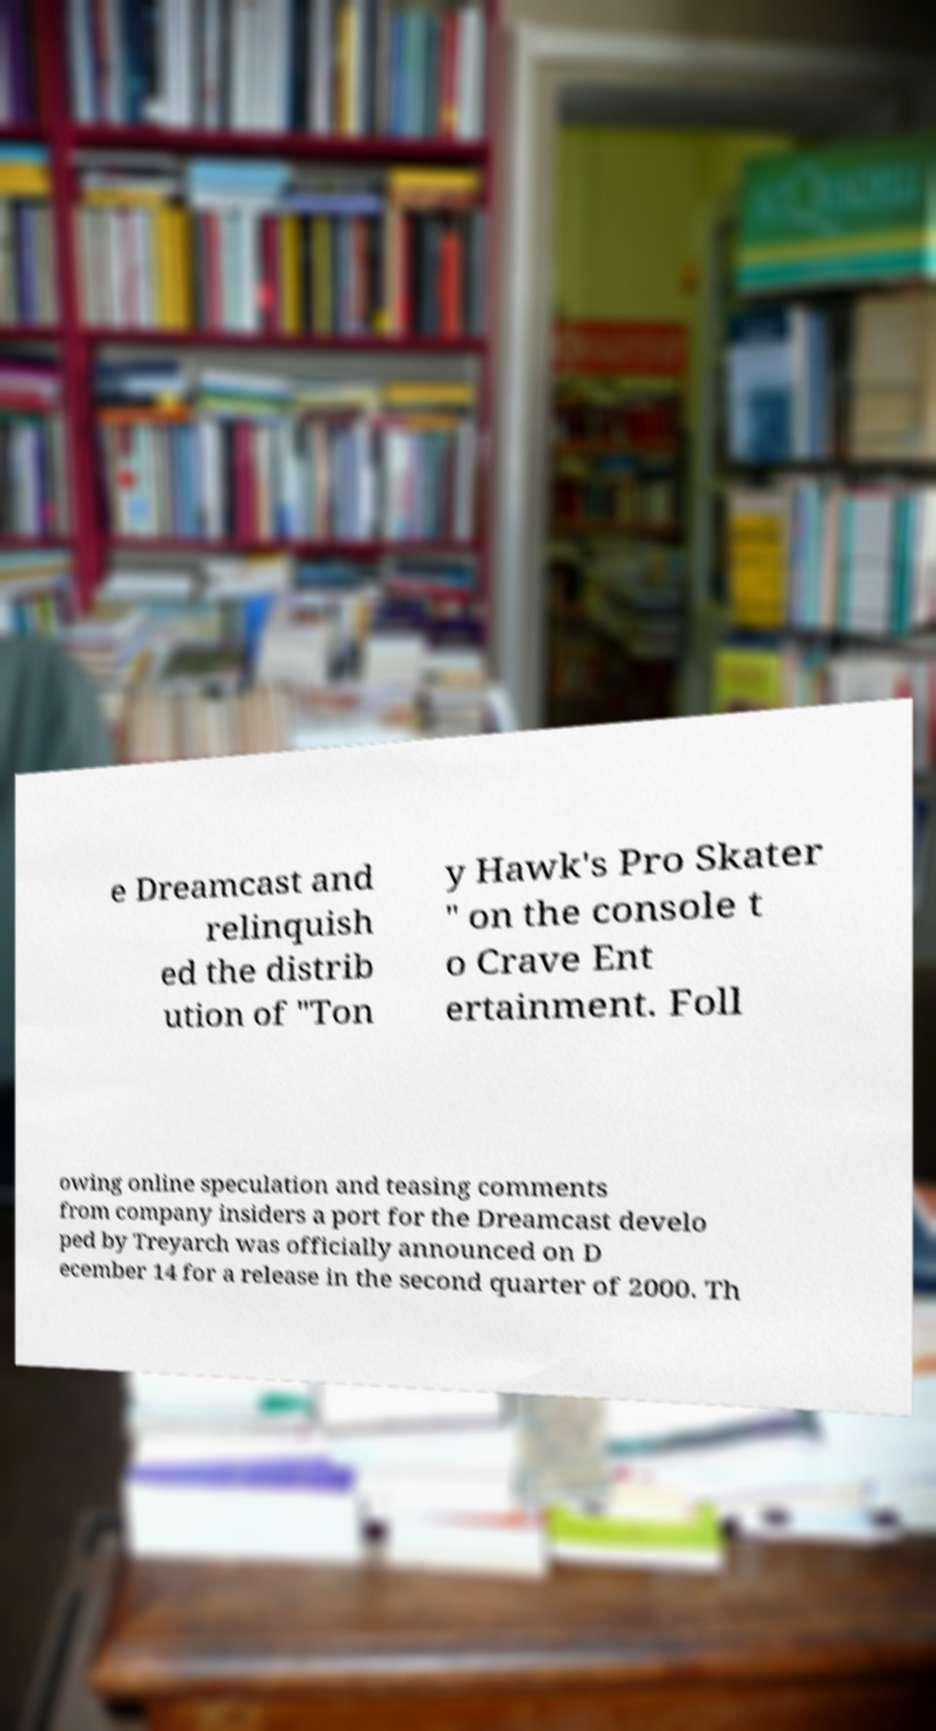Please read and relay the text visible in this image. What does it say? e Dreamcast and relinquish ed the distrib ution of "Ton y Hawk's Pro Skater " on the console t o Crave Ent ertainment. Foll owing online speculation and teasing comments from company insiders a port for the Dreamcast develo ped by Treyarch was officially announced on D ecember 14 for a release in the second quarter of 2000. Th 